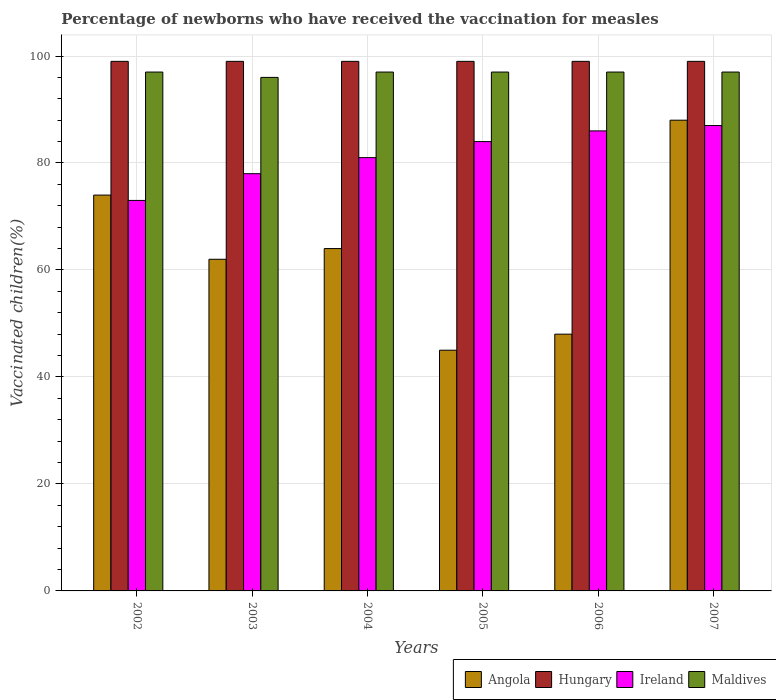Are the number of bars per tick equal to the number of legend labels?
Offer a terse response. Yes. Are the number of bars on each tick of the X-axis equal?
Offer a terse response. Yes. What is the label of the 6th group of bars from the left?
Provide a succinct answer. 2007. In how many cases, is the number of bars for a given year not equal to the number of legend labels?
Ensure brevity in your answer.  0. What is the percentage of vaccinated children in Angola in 2007?
Keep it short and to the point. 88. Across all years, what is the maximum percentage of vaccinated children in Hungary?
Give a very brief answer. 99. In which year was the percentage of vaccinated children in Ireland maximum?
Your answer should be very brief. 2007. What is the total percentage of vaccinated children in Maldives in the graph?
Your answer should be very brief. 581. What is the difference between the percentage of vaccinated children in Angola in 2004 and that in 2007?
Your answer should be very brief. -24. What is the difference between the percentage of vaccinated children in Angola in 2007 and the percentage of vaccinated children in Maldives in 2002?
Provide a short and direct response. -9. What is the average percentage of vaccinated children in Ireland per year?
Make the answer very short. 81.5. What is the ratio of the percentage of vaccinated children in Angola in 2002 to that in 2004?
Provide a short and direct response. 1.16. What is the difference between the highest and the lowest percentage of vaccinated children in Hungary?
Your response must be concise. 0. In how many years, is the percentage of vaccinated children in Ireland greater than the average percentage of vaccinated children in Ireland taken over all years?
Provide a short and direct response. 3. Is the sum of the percentage of vaccinated children in Ireland in 2006 and 2007 greater than the maximum percentage of vaccinated children in Angola across all years?
Keep it short and to the point. Yes. What does the 4th bar from the left in 2003 represents?
Make the answer very short. Maldives. What does the 1st bar from the right in 2002 represents?
Your answer should be very brief. Maldives. Is it the case that in every year, the sum of the percentage of vaccinated children in Angola and percentage of vaccinated children in Maldives is greater than the percentage of vaccinated children in Hungary?
Make the answer very short. Yes. How many bars are there?
Offer a terse response. 24. How many years are there in the graph?
Make the answer very short. 6. What is the difference between two consecutive major ticks on the Y-axis?
Your answer should be compact. 20. Does the graph contain any zero values?
Your response must be concise. No. Where does the legend appear in the graph?
Keep it short and to the point. Bottom right. How many legend labels are there?
Make the answer very short. 4. What is the title of the graph?
Your answer should be compact. Percentage of newborns who have received the vaccination for measles. Does "Tonga" appear as one of the legend labels in the graph?
Give a very brief answer. No. What is the label or title of the Y-axis?
Your answer should be compact. Vaccinated children(%). What is the Vaccinated children(%) of Angola in 2002?
Offer a terse response. 74. What is the Vaccinated children(%) of Hungary in 2002?
Your answer should be very brief. 99. What is the Vaccinated children(%) in Maldives in 2002?
Your response must be concise. 97. What is the Vaccinated children(%) of Ireland in 2003?
Provide a short and direct response. 78. What is the Vaccinated children(%) of Maldives in 2003?
Keep it short and to the point. 96. What is the Vaccinated children(%) of Angola in 2004?
Make the answer very short. 64. What is the Vaccinated children(%) of Ireland in 2004?
Your response must be concise. 81. What is the Vaccinated children(%) of Maldives in 2004?
Offer a terse response. 97. What is the Vaccinated children(%) in Hungary in 2005?
Ensure brevity in your answer.  99. What is the Vaccinated children(%) in Ireland in 2005?
Provide a succinct answer. 84. What is the Vaccinated children(%) in Maldives in 2005?
Your response must be concise. 97. What is the Vaccinated children(%) of Ireland in 2006?
Provide a succinct answer. 86. What is the Vaccinated children(%) of Maldives in 2006?
Keep it short and to the point. 97. What is the Vaccinated children(%) in Angola in 2007?
Make the answer very short. 88. What is the Vaccinated children(%) in Hungary in 2007?
Your answer should be very brief. 99. What is the Vaccinated children(%) of Maldives in 2007?
Keep it short and to the point. 97. Across all years, what is the maximum Vaccinated children(%) in Ireland?
Offer a very short reply. 87. Across all years, what is the maximum Vaccinated children(%) in Maldives?
Offer a very short reply. 97. Across all years, what is the minimum Vaccinated children(%) of Maldives?
Ensure brevity in your answer.  96. What is the total Vaccinated children(%) in Angola in the graph?
Provide a succinct answer. 381. What is the total Vaccinated children(%) of Hungary in the graph?
Your answer should be very brief. 594. What is the total Vaccinated children(%) of Ireland in the graph?
Keep it short and to the point. 489. What is the total Vaccinated children(%) in Maldives in the graph?
Offer a very short reply. 581. What is the difference between the Vaccinated children(%) of Angola in 2002 and that in 2004?
Provide a short and direct response. 10. What is the difference between the Vaccinated children(%) in Hungary in 2002 and that in 2005?
Give a very brief answer. 0. What is the difference between the Vaccinated children(%) of Ireland in 2002 and that in 2005?
Make the answer very short. -11. What is the difference between the Vaccinated children(%) of Angola in 2002 and that in 2006?
Offer a very short reply. 26. What is the difference between the Vaccinated children(%) of Hungary in 2002 and that in 2006?
Provide a short and direct response. 0. What is the difference between the Vaccinated children(%) in Ireland in 2002 and that in 2006?
Offer a very short reply. -13. What is the difference between the Vaccinated children(%) of Maldives in 2002 and that in 2006?
Give a very brief answer. 0. What is the difference between the Vaccinated children(%) in Angola in 2002 and that in 2007?
Make the answer very short. -14. What is the difference between the Vaccinated children(%) of Maldives in 2002 and that in 2007?
Your answer should be compact. 0. What is the difference between the Vaccinated children(%) of Ireland in 2003 and that in 2004?
Keep it short and to the point. -3. What is the difference between the Vaccinated children(%) in Maldives in 2003 and that in 2004?
Your response must be concise. -1. What is the difference between the Vaccinated children(%) of Hungary in 2003 and that in 2005?
Offer a terse response. 0. What is the difference between the Vaccinated children(%) in Ireland in 2003 and that in 2005?
Offer a terse response. -6. What is the difference between the Vaccinated children(%) in Angola in 2003 and that in 2006?
Your answer should be very brief. 14. What is the difference between the Vaccinated children(%) of Hungary in 2003 and that in 2006?
Offer a terse response. 0. What is the difference between the Vaccinated children(%) in Ireland in 2003 and that in 2006?
Ensure brevity in your answer.  -8. What is the difference between the Vaccinated children(%) of Angola in 2003 and that in 2007?
Give a very brief answer. -26. What is the difference between the Vaccinated children(%) in Maldives in 2004 and that in 2005?
Offer a terse response. 0. What is the difference between the Vaccinated children(%) of Hungary in 2004 and that in 2006?
Provide a succinct answer. 0. What is the difference between the Vaccinated children(%) of Ireland in 2004 and that in 2006?
Ensure brevity in your answer.  -5. What is the difference between the Vaccinated children(%) of Ireland in 2004 and that in 2007?
Provide a short and direct response. -6. What is the difference between the Vaccinated children(%) in Angola in 2005 and that in 2007?
Your response must be concise. -43. What is the difference between the Vaccinated children(%) in Maldives in 2005 and that in 2007?
Offer a very short reply. 0. What is the difference between the Vaccinated children(%) of Angola in 2006 and that in 2007?
Your answer should be compact. -40. What is the difference between the Vaccinated children(%) of Angola in 2002 and the Vaccinated children(%) of Hungary in 2003?
Provide a succinct answer. -25. What is the difference between the Vaccinated children(%) of Angola in 2002 and the Vaccinated children(%) of Maldives in 2003?
Offer a terse response. -22. What is the difference between the Vaccinated children(%) of Hungary in 2002 and the Vaccinated children(%) of Maldives in 2003?
Provide a short and direct response. 3. What is the difference between the Vaccinated children(%) in Ireland in 2002 and the Vaccinated children(%) in Maldives in 2003?
Your answer should be very brief. -23. What is the difference between the Vaccinated children(%) in Angola in 2002 and the Vaccinated children(%) in Ireland in 2004?
Provide a short and direct response. -7. What is the difference between the Vaccinated children(%) in Angola in 2002 and the Vaccinated children(%) in Maldives in 2004?
Provide a succinct answer. -23. What is the difference between the Vaccinated children(%) in Hungary in 2002 and the Vaccinated children(%) in Ireland in 2004?
Ensure brevity in your answer.  18. What is the difference between the Vaccinated children(%) in Ireland in 2002 and the Vaccinated children(%) in Maldives in 2004?
Your answer should be very brief. -24. What is the difference between the Vaccinated children(%) in Angola in 2002 and the Vaccinated children(%) in Ireland in 2005?
Give a very brief answer. -10. What is the difference between the Vaccinated children(%) in Hungary in 2002 and the Vaccinated children(%) in Ireland in 2005?
Make the answer very short. 15. What is the difference between the Vaccinated children(%) in Hungary in 2002 and the Vaccinated children(%) in Maldives in 2005?
Provide a succinct answer. 2. What is the difference between the Vaccinated children(%) of Angola in 2002 and the Vaccinated children(%) of Hungary in 2007?
Your answer should be compact. -25. What is the difference between the Vaccinated children(%) in Angola in 2002 and the Vaccinated children(%) in Ireland in 2007?
Offer a terse response. -13. What is the difference between the Vaccinated children(%) of Hungary in 2002 and the Vaccinated children(%) of Maldives in 2007?
Make the answer very short. 2. What is the difference between the Vaccinated children(%) in Ireland in 2002 and the Vaccinated children(%) in Maldives in 2007?
Offer a terse response. -24. What is the difference between the Vaccinated children(%) in Angola in 2003 and the Vaccinated children(%) in Hungary in 2004?
Offer a very short reply. -37. What is the difference between the Vaccinated children(%) in Angola in 2003 and the Vaccinated children(%) in Ireland in 2004?
Your answer should be very brief. -19. What is the difference between the Vaccinated children(%) in Angola in 2003 and the Vaccinated children(%) in Maldives in 2004?
Keep it short and to the point. -35. What is the difference between the Vaccinated children(%) in Hungary in 2003 and the Vaccinated children(%) in Ireland in 2004?
Keep it short and to the point. 18. What is the difference between the Vaccinated children(%) of Angola in 2003 and the Vaccinated children(%) of Hungary in 2005?
Give a very brief answer. -37. What is the difference between the Vaccinated children(%) in Angola in 2003 and the Vaccinated children(%) in Ireland in 2005?
Provide a succinct answer. -22. What is the difference between the Vaccinated children(%) of Angola in 2003 and the Vaccinated children(%) of Maldives in 2005?
Your answer should be compact. -35. What is the difference between the Vaccinated children(%) of Hungary in 2003 and the Vaccinated children(%) of Ireland in 2005?
Your answer should be compact. 15. What is the difference between the Vaccinated children(%) in Hungary in 2003 and the Vaccinated children(%) in Maldives in 2005?
Your answer should be very brief. 2. What is the difference between the Vaccinated children(%) of Angola in 2003 and the Vaccinated children(%) of Hungary in 2006?
Your response must be concise. -37. What is the difference between the Vaccinated children(%) in Angola in 2003 and the Vaccinated children(%) in Maldives in 2006?
Your answer should be compact. -35. What is the difference between the Vaccinated children(%) in Hungary in 2003 and the Vaccinated children(%) in Maldives in 2006?
Offer a terse response. 2. What is the difference between the Vaccinated children(%) of Angola in 2003 and the Vaccinated children(%) of Hungary in 2007?
Provide a succinct answer. -37. What is the difference between the Vaccinated children(%) of Angola in 2003 and the Vaccinated children(%) of Ireland in 2007?
Provide a succinct answer. -25. What is the difference between the Vaccinated children(%) in Angola in 2003 and the Vaccinated children(%) in Maldives in 2007?
Make the answer very short. -35. What is the difference between the Vaccinated children(%) in Angola in 2004 and the Vaccinated children(%) in Hungary in 2005?
Your response must be concise. -35. What is the difference between the Vaccinated children(%) in Angola in 2004 and the Vaccinated children(%) in Ireland in 2005?
Your answer should be compact. -20. What is the difference between the Vaccinated children(%) of Angola in 2004 and the Vaccinated children(%) of Maldives in 2005?
Offer a very short reply. -33. What is the difference between the Vaccinated children(%) in Hungary in 2004 and the Vaccinated children(%) in Ireland in 2005?
Your answer should be very brief. 15. What is the difference between the Vaccinated children(%) in Hungary in 2004 and the Vaccinated children(%) in Maldives in 2005?
Your answer should be compact. 2. What is the difference between the Vaccinated children(%) of Angola in 2004 and the Vaccinated children(%) of Hungary in 2006?
Offer a very short reply. -35. What is the difference between the Vaccinated children(%) of Angola in 2004 and the Vaccinated children(%) of Ireland in 2006?
Provide a succinct answer. -22. What is the difference between the Vaccinated children(%) of Angola in 2004 and the Vaccinated children(%) of Maldives in 2006?
Your response must be concise. -33. What is the difference between the Vaccinated children(%) in Hungary in 2004 and the Vaccinated children(%) in Ireland in 2006?
Give a very brief answer. 13. What is the difference between the Vaccinated children(%) in Ireland in 2004 and the Vaccinated children(%) in Maldives in 2006?
Make the answer very short. -16. What is the difference between the Vaccinated children(%) in Angola in 2004 and the Vaccinated children(%) in Hungary in 2007?
Offer a very short reply. -35. What is the difference between the Vaccinated children(%) in Angola in 2004 and the Vaccinated children(%) in Maldives in 2007?
Make the answer very short. -33. What is the difference between the Vaccinated children(%) of Hungary in 2004 and the Vaccinated children(%) of Ireland in 2007?
Provide a succinct answer. 12. What is the difference between the Vaccinated children(%) in Angola in 2005 and the Vaccinated children(%) in Hungary in 2006?
Offer a terse response. -54. What is the difference between the Vaccinated children(%) of Angola in 2005 and the Vaccinated children(%) of Ireland in 2006?
Offer a very short reply. -41. What is the difference between the Vaccinated children(%) in Angola in 2005 and the Vaccinated children(%) in Maldives in 2006?
Give a very brief answer. -52. What is the difference between the Vaccinated children(%) of Angola in 2005 and the Vaccinated children(%) of Hungary in 2007?
Ensure brevity in your answer.  -54. What is the difference between the Vaccinated children(%) of Angola in 2005 and the Vaccinated children(%) of Ireland in 2007?
Offer a terse response. -42. What is the difference between the Vaccinated children(%) in Angola in 2005 and the Vaccinated children(%) in Maldives in 2007?
Offer a very short reply. -52. What is the difference between the Vaccinated children(%) of Hungary in 2005 and the Vaccinated children(%) of Ireland in 2007?
Provide a succinct answer. 12. What is the difference between the Vaccinated children(%) in Angola in 2006 and the Vaccinated children(%) in Hungary in 2007?
Make the answer very short. -51. What is the difference between the Vaccinated children(%) of Angola in 2006 and the Vaccinated children(%) of Ireland in 2007?
Provide a succinct answer. -39. What is the difference between the Vaccinated children(%) of Angola in 2006 and the Vaccinated children(%) of Maldives in 2007?
Ensure brevity in your answer.  -49. What is the difference between the Vaccinated children(%) of Hungary in 2006 and the Vaccinated children(%) of Ireland in 2007?
Give a very brief answer. 12. What is the average Vaccinated children(%) of Angola per year?
Offer a very short reply. 63.5. What is the average Vaccinated children(%) in Ireland per year?
Your answer should be compact. 81.5. What is the average Vaccinated children(%) of Maldives per year?
Ensure brevity in your answer.  96.83. In the year 2002, what is the difference between the Vaccinated children(%) in Angola and Vaccinated children(%) in Hungary?
Provide a succinct answer. -25. In the year 2002, what is the difference between the Vaccinated children(%) of Hungary and Vaccinated children(%) of Maldives?
Offer a terse response. 2. In the year 2002, what is the difference between the Vaccinated children(%) of Ireland and Vaccinated children(%) of Maldives?
Your answer should be compact. -24. In the year 2003, what is the difference between the Vaccinated children(%) in Angola and Vaccinated children(%) in Hungary?
Offer a very short reply. -37. In the year 2003, what is the difference between the Vaccinated children(%) in Angola and Vaccinated children(%) in Ireland?
Ensure brevity in your answer.  -16. In the year 2003, what is the difference between the Vaccinated children(%) in Angola and Vaccinated children(%) in Maldives?
Give a very brief answer. -34. In the year 2003, what is the difference between the Vaccinated children(%) of Hungary and Vaccinated children(%) of Ireland?
Provide a succinct answer. 21. In the year 2004, what is the difference between the Vaccinated children(%) in Angola and Vaccinated children(%) in Hungary?
Provide a succinct answer. -35. In the year 2004, what is the difference between the Vaccinated children(%) in Angola and Vaccinated children(%) in Maldives?
Your answer should be compact. -33. In the year 2004, what is the difference between the Vaccinated children(%) in Hungary and Vaccinated children(%) in Ireland?
Your answer should be compact. 18. In the year 2004, what is the difference between the Vaccinated children(%) in Hungary and Vaccinated children(%) in Maldives?
Your response must be concise. 2. In the year 2004, what is the difference between the Vaccinated children(%) in Ireland and Vaccinated children(%) in Maldives?
Give a very brief answer. -16. In the year 2005, what is the difference between the Vaccinated children(%) of Angola and Vaccinated children(%) of Hungary?
Provide a short and direct response. -54. In the year 2005, what is the difference between the Vaccinated children(%) in Angola and Vaccinated children(%) in Ireland?
Offer a very short reply. -39. In the year 2005, what is the difference between the Vaccinated children(%) of Angola and Vaccinated children(%) of Maldives?
Provide a short and direct response. -52. In the year 2005, what is the difference between the Vaccinated children(%) in Hungary and Vaccinated children(%) in Ireland?
Your answer should be compact. 15. In the year 2005, what is the difference between the Vaccinated children(%) of Hungary and Vaccinated children(%) of Maldives?
Keep it short and to the point. 2. In the year 2006, what is the difference between the Vaccinated children(%) in Angola and Vaccinated children(%) in Hungary?
Provide a short and direct response. -51. In the year 2006, what is the difference between the Vaccinated children(%) of Angola and Vaccinated children(%) of Ireland?
Your answer should be compact. -38. In the year 2006, what is the difference between the Vaccinated children(%) in Angola and Vaccinated children(%) in Maldives?
Keep it short and to the point. -49. In the year 2006, what is the difference between the Vaccinated children(%) in Hungary and Vaccinated children(%) in Maldives?
Keep it short and to the point. 2. In the year 2006, what is the difference between the Vaccinated children(%) of Ireland and Vaccinated children(%) of Maldives?
Keep it short and to the point. -11. In the year 2007, what is the difference between the Vaccinated children(%) of Angola and Vaccinated children(%) of Hungary?
Give a very brief answer. -11. In the year 2007, what is the difference between the Vaccinated children(%) in Angola and Vaccinated children(%) in Ireland?
Keep it short and to the point. 1. In the year 2007, what is the difference between the Vaccinated children(%) of Hungary and Vaccinated children(%) of Ireland?
Keep it short and to the point. 12. What is the ratio of the Vaccinated children(%) of Angola in 2002 to that in 2003?
Your answer should be compact. 1.19. What is the ratio of the Vaccinated children(%) of Ireland in 2002 to that in 2003?
Provide a short and direct response. 0.94. What is the ratio of the Vaccinated children(%) of Maldives in 2002 to that in 2003?
Your answer should be compact. 1.01. What is the ratio of the Vaccinated children(%) of Angola in 2002 to that in 2004?
Keep it short and to the point. 1.16. What is the ratio of the Vaccinated children(%) of Hungary in 2002 to that in 2004?
Your answer should be compact. 1. What is the ratio of the Vaccinated children(%) of Ireland in 2002 to that in 2004?
Ensure brevity in your answer.  0.9. What is the ratio of the Vaccinated children(%) of Maldives in 2002 to that in 2004?
Ensure brevity in your answer.  1. What is the ratio of the Vaccinated children(%) of Angola in 2002 to that in 2005?
Provide a succinct answer. 1.64. What is the ratio of the Vaccinated children(%) of Ireland in 2002 to that in 2005?
Your response must be concise. 0.87. What is the ratio of the Vaccinated children(%) in Angola in 2002 to that in 2006?
Keep it short and to the point. 1.54. What is the ratio of the Vaccinated children(%) in Ireland in 2002 to that in 2006?
Your answer should be very brief. 0.85. What is the ratio of the Vaccinated children(%) of Angola in 2002 to that in 2007?
Provide a short and direct response. 0.84. What is the ratio of the Vaccinated children(%) in Ireland in 2002 to that in 2007?
Provide a short and direct response. 0.84. What is the ratio of the Vaccinated children(%) of Angola in 2003 to that in 2004?
Your answer should be very brief. 0.97. What is the ratio of the Vaccinated children(%) in Hungary in 2003 to that in 2004?
Give a very brief answer. 1. What is the ratio of the Vaccinated children(%) of Angola in 2003 to that in 2005?
Provide a succinct answer. 1.38. What is the ratio of the Vaccinated children(%) of Hungary in 2003 to that in 2005?
Your answer should be compact. 1. What is the ratio of the Vaccinated children(%) in Ireland in 2003 to that in 2005?
Give a very brief answer. 0.93. What is the ratio of the Vaccinated children(%) in Angola in 2003 to that in 2006?
Offer a terse response. 1.29. What is the ratio of the Vaccinated children(%) of Ireland in 2003 to that in 2006?
Offer a very short reply. 0.91. What is the ratio of the Vaccinated children(%) in Angola in 2003 to that in 2007?
Give a very brief answer. 0.7. What is the ratio of the Vaccinated children(%) in Hungary in 2003 to that in 2007?
Your answer should be very brief. 1. What is the ratio of the Vaccinated children(%) of Ireland in 2003 to that in 2007?
Your response must be concise. 0.9. What is the ratio of the Vaccinated children(%) in Angola in 2004 to that in 2005?
Offer a very short reply. 1.42. What is the ratio of the Vaccinated children(%) in Ireland in 2004 to that in 2005?
Offer a very short reply. 0.96. What is the ratio of the Vaccinated children(%) of Maldives in 2004 to that in 2005?
Provide a succinct answer. 1. What is the ratio of the Vaccinated children(%) in Angola in 2004 to that in 2006?
Your answer should be very brief. 1.33. What is the ratio of the Vaccinated children(%) in Hungary in 2004 to that in 2006?
Ensure brevity in your answer.  1. What is the ratio of the Vaccinated children(%) of Ireland in 2004 to that in 2006?
Your answer should be very brief. 0.94. What is the ratio of the Vaccinated children(%) in Angola in 2004 to that in 2007?
Make the answer very short. 0.73. What is the ratio of the Vaccinated children(%) of Hungary in 2004 to that in 2007?
Make the answer very short. 1. What is the ratio of the Vaccinated children(%) in Ireland in 2004 to that in 2007?
Provide a short and direct response. 0.93. What is the ratio of the Vaccinated children(%) in Hungary in 2005 to that in 2006?
Provide a succinct answer. 1. What is the ratio of the Vaccinated children(%) in Ireland in 2005 to that in 2006?
Ensure brevity in your answer.  0.98. What is the ratio of the Vaccinated children(%) of Maldives in 2005 to that in 2006?
Offer a very short reply. 1. What is the ratio of the Vaccinated children(%) in Angola in 2005 to that in 2007?
Give a very brief answer. 0.51. What is the ratio of the Vaccinated children(%) in Hungary in 2005 to that in 2007?
Ensure brevity in your answer.  1. What is the ratio of the Vaccinated children(%) in Ireland in 2005 to that in 2007?
Your response must be concise. 0.97. What is the ratio of the Vaccinated children(%) of Angola in 2006 to that in 2007?
Ensure brevity in your answer.  0.55. What is the difference between the highest and the lowest Vaccinated children(%) in Angola?
Ensure brevity in your answer.  43. What is the difference between the highest and the lowest Vaccinated children(%) of Hungary?
Keep it short and to the point. 0. What is the difference between the highest and the lowest Vaccinated children(%) of Ireland?
Keep it short and to the point. 14. 